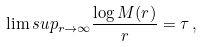Convert formula to latex. <formula><loc_0><loc_0><loc_500><loc_500>\lim s u p _ { r \to \infty } \frac { \log M ( r ) } { r } = \tau \, ,</formula> 